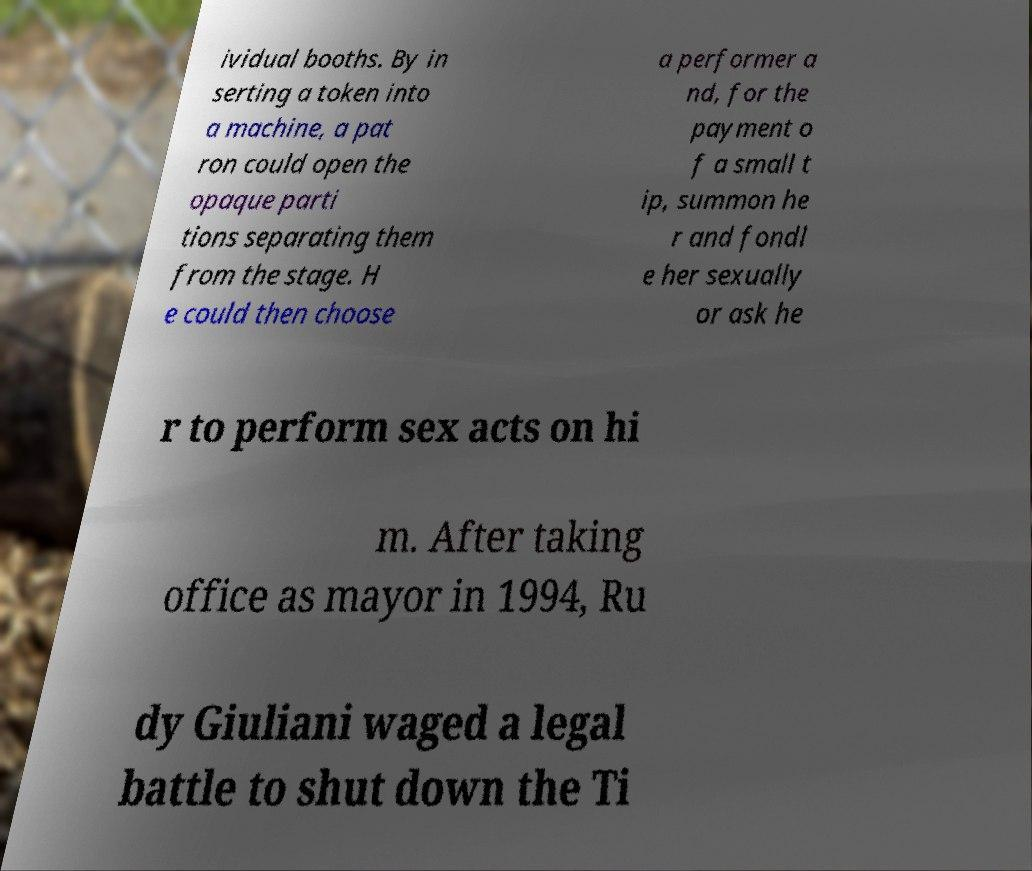What messages or text are displayed in this image? I need them in a readable, typed format. ividual booths. By in serting a token into a machine, a pat ron could open the opaque parti tions separating them from the stage. H e could then choose a performer a nd, for the payment o f a small t ip, summon he r and fondl e her sexually or ask he r to perform sex acts on hi m. After taking office as mayor in 1994, Ru dy Giuliani waged a legal battle to shut down the Ti 